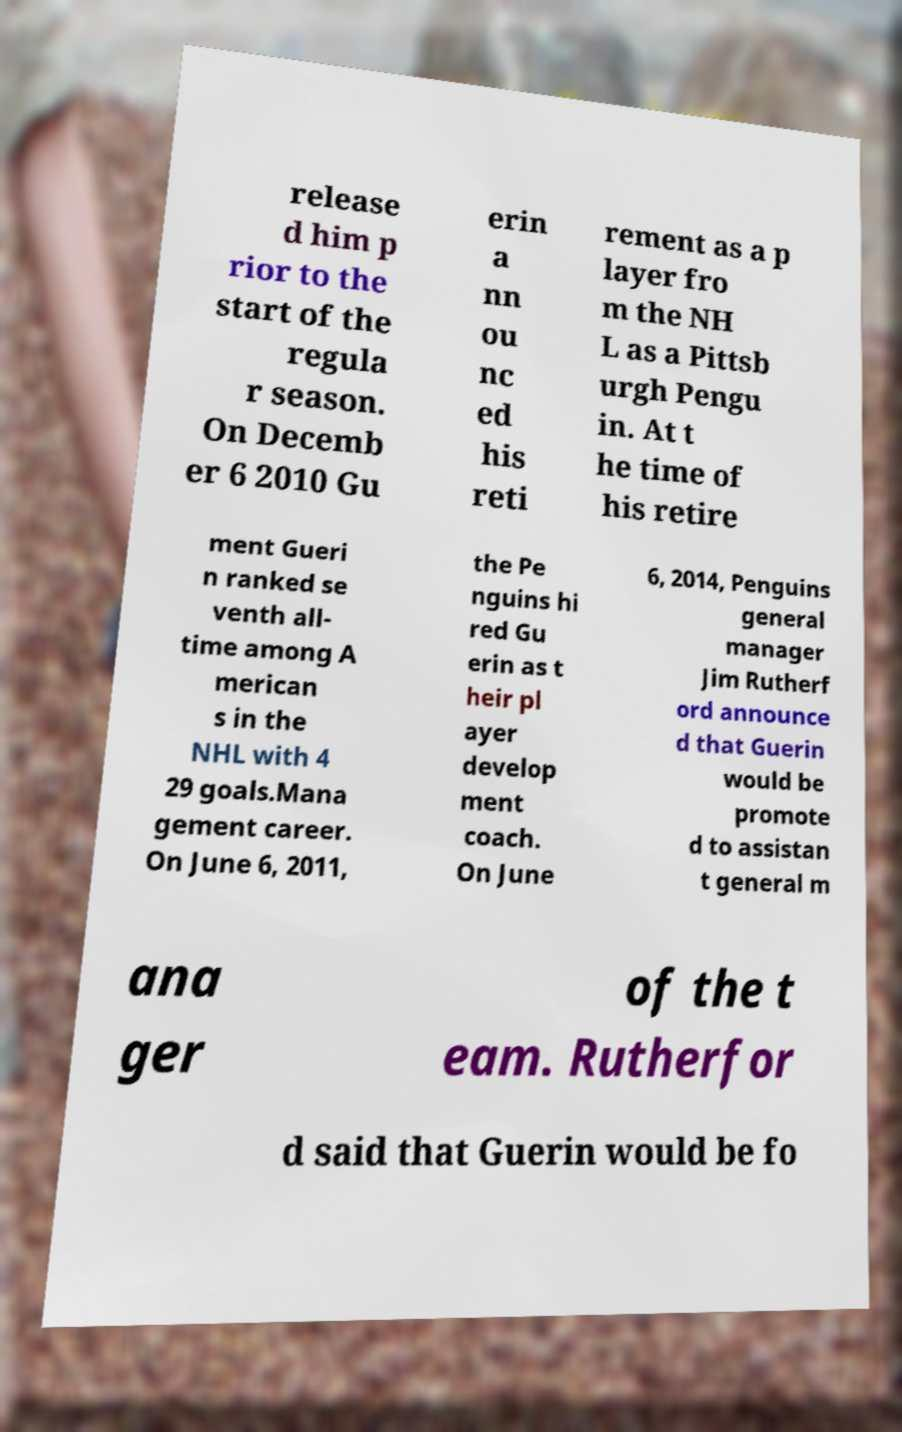Please read and relay the text visible in this image. What does it say? release d him p rior to the start of the regula r season. On Decemb er 6 2010 Gu erin a nn ou nc ed his reti rement as a p layer fro m the NH L as a Pittsb urgh Pengu in. At t he time of his retire ment Gueri n ranked se venth all- time among A merican s in the NHL with 4 29 goals.Mana gement career. On June 6, 2011, the Pe nguins hi red Gu erin as t heir pl ayer develop ment coach. On June 6, 2014, Penguins general manager Jim Rutherf ord announce d that Guerin would be promote d to assistan t general m ana ger of the t eam. Rutherfor d said that Guerin would be fo 